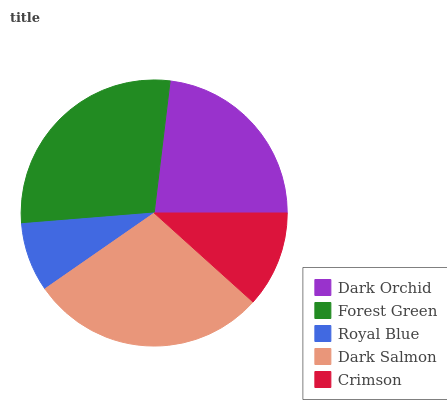Is Royal Blue the minimum?
Answer yes or no. Yes. Is Dark Salmon the maximum?
Answer yes or no. Yes. Is Forest Green the minimum?
Answer yes or no. No. Is Forest Green the maximum?
Answer yes or no. No. Is Forest Green greater than Dark Orchid?
Answer yes or no. Yes. Is Dark Orchid less than Forest Green?
Answer yes or no. Yes. Is Dark Orchid greater than Forest Green?
Answer yes or no. No. Is Forest Green less than Dark Orchid?
Answer yes or no. No. Is Dark Orchid the high median?
Answer yes or no. Yes. Is Dark Orchid the low median?
Answer yes or no. Yes. Is Dark Salmon the high median?
Answer yes or no. No. Is Royal Blue the low median?
Answer yes or no. No. 